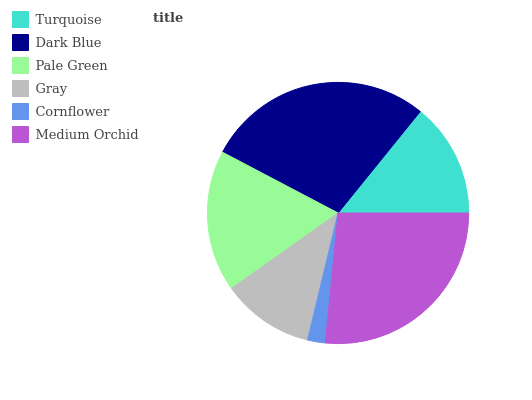Is Cornflower the minimum?
Answer yes or no. Yes. Is Dark Blue the maximum?
Answer yes or no. Yes. Is Pale Green the minimum?
Answer yes or no. No. Is Pale Green the maximum?
Answer yes or no. No. Is Dark Blue greater than Pale Green?
Answer yes or no. Yes. Is Pale Green less than Dark Blue?
Answer yes or no. Yes. Is Pale Green greater than Dark Blue?
Answer yes or no. No. Is Dark Blue less than Pale Green?
Answer yes or no. No. Is Pale Green the high median?
Answer yes or no. Yes. Is Turquoise the low median?
Answer yes or no. Yes. Is Gray the high median?
Answer yes or no. No. Is Cornflower the low median?
Answer yes or no. No. 